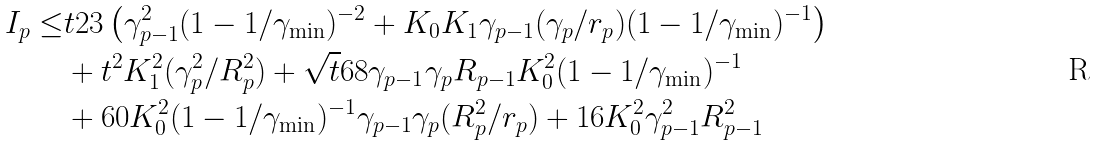<formula> <loc_0><loc_0><loc_500><loc_500>I _ { p } \leq & t 2 3 \left ( \gamma _ { p - 1 } ^ { 2 } ( 1 - 1 / \gamma _ { \min } ) ^ { - 2 } + K _ { 0 } K _ { 1 } \gamma _ { p - 1 } ( \gamma _ { p } / r _ { p } ) ( 1 - 1 / \gamma _ { \min } ) ^ { - 1 } \right ) \\ & + t ^ { 2 } K _ { 1 } ^ { 2 } ( \gamma _ { p } ^ { 2 } / R _ { p } ^ { 2 } ) + \sqrt { t } 6 8 \gamma _ { p - 1 } \gamma _ { p } R _ { p - 1 } K _ { 0 } ^ { 2 } ( 1 - 1 / \gamma _ { \min } ) ^ { - 1 } \\ & + 6 0 K _ { 0 } ^ { 2 } ( 1 - 1 / \gamma _ { \min } ) ^ { - 1 } \gamma _ { p - 1 } \gamma _ { p } ( R _ { p } ^ { 2 } / r _ { p } ) + 1 6 K _ { 0 } ^ { 2 } \gamma _ { p - 1 } ^ { 2 } R _ { p - 1 } ^ { 2 }</formula> 